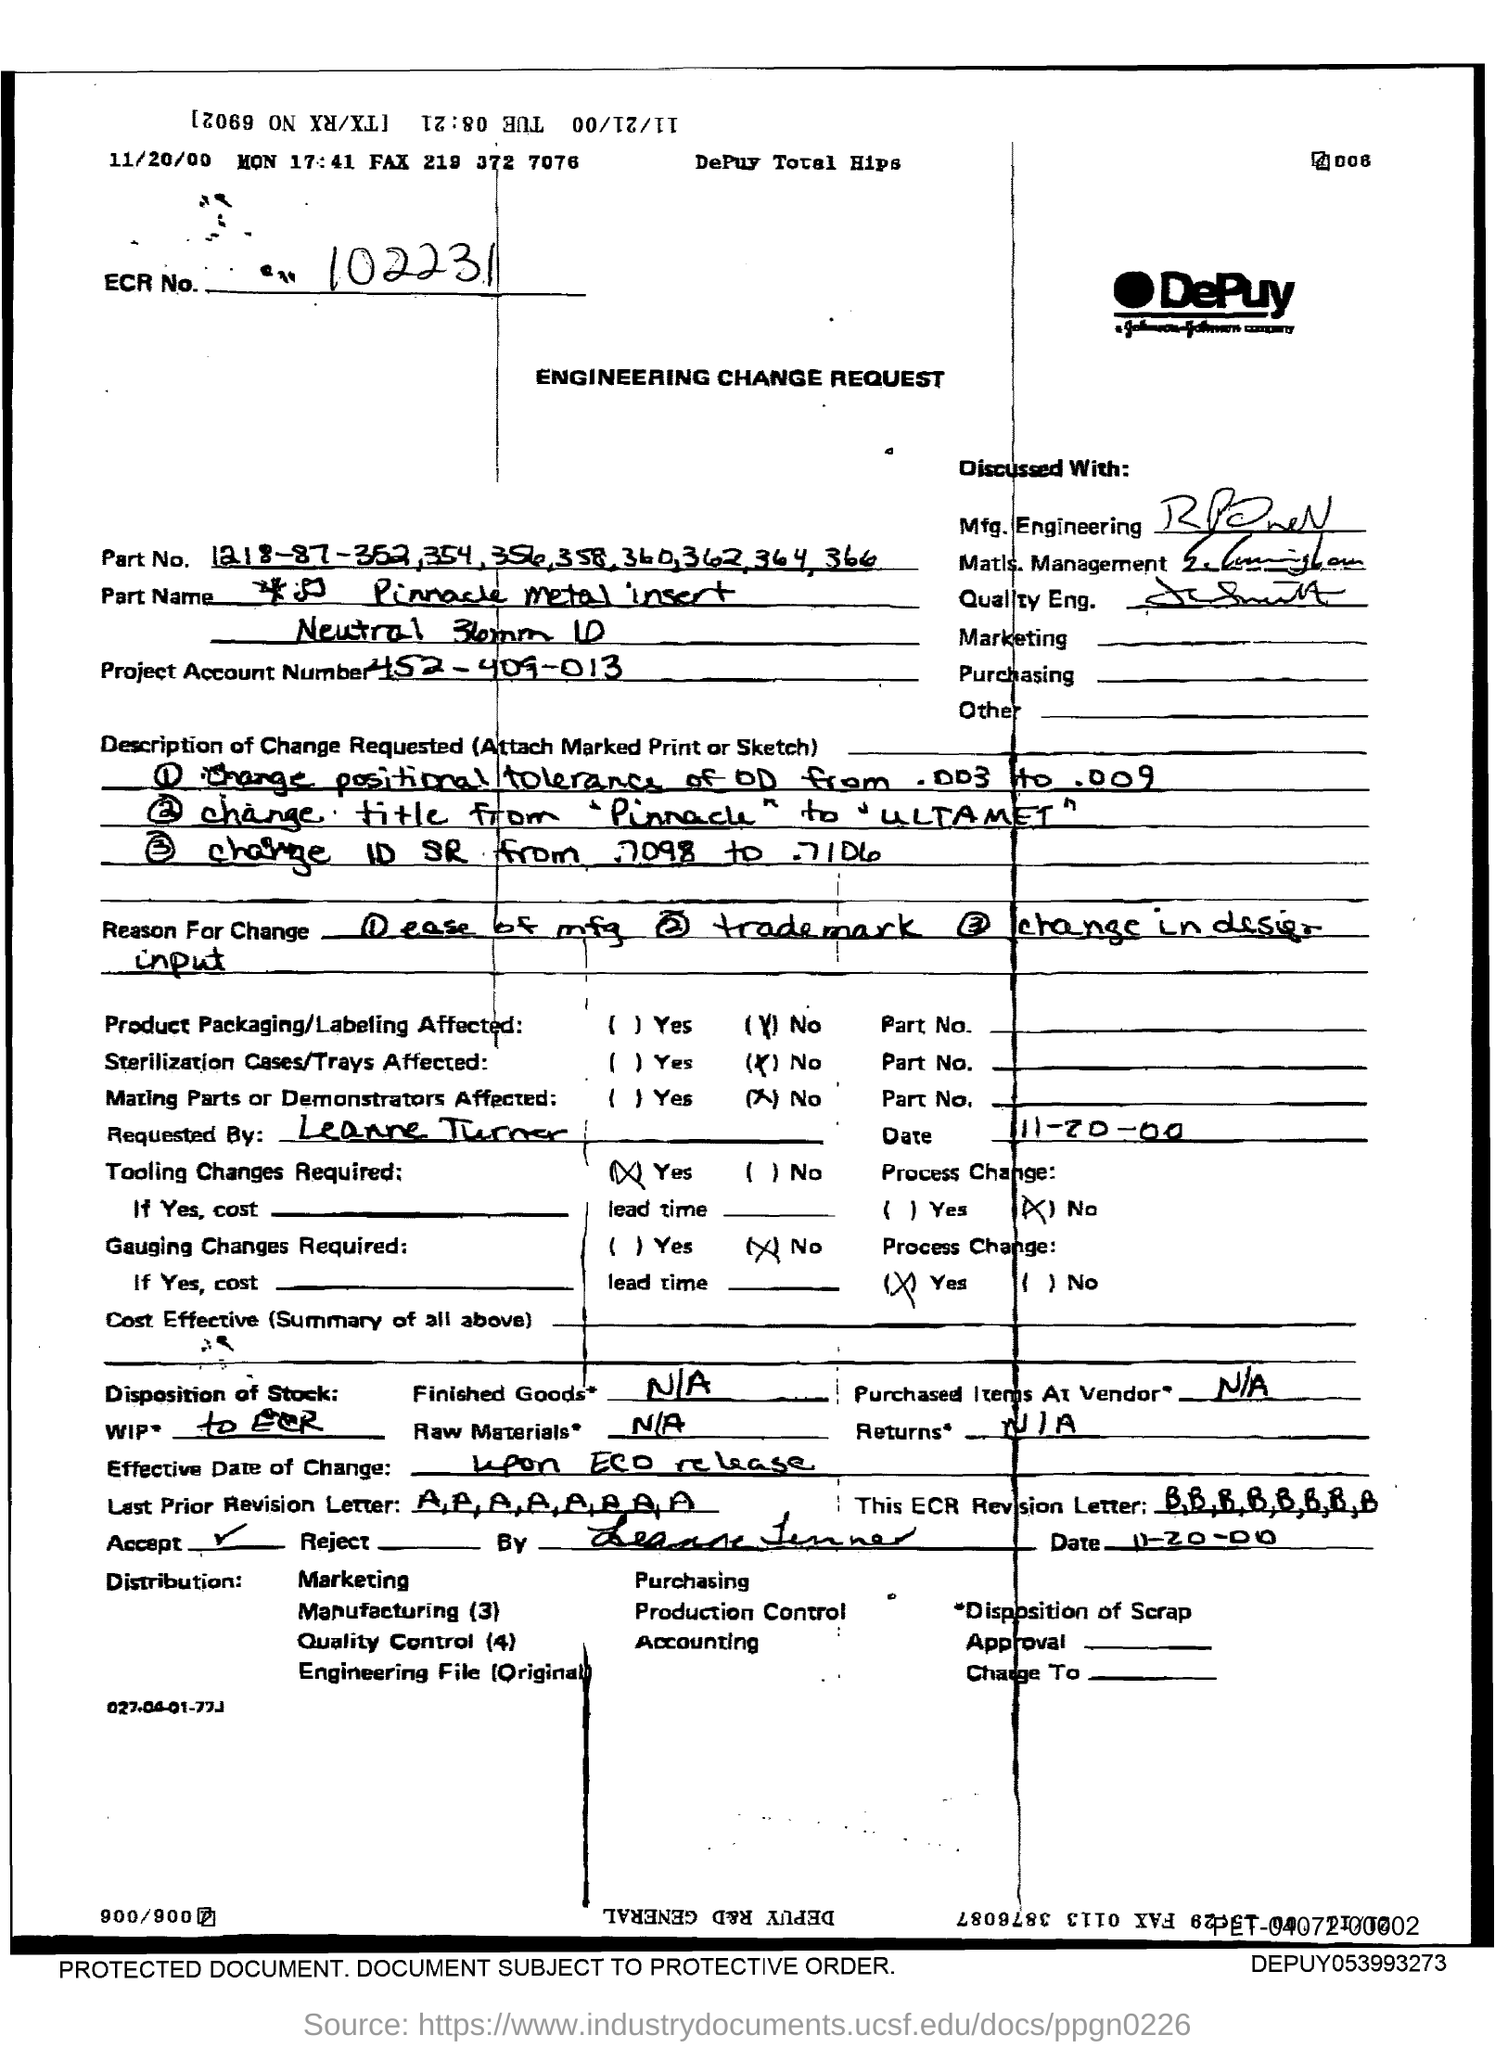What is the ECR No in the document?
Offer a terse response. 102231. What is the Project Account Number?
Provide a succinct answer. 452-409-013. 